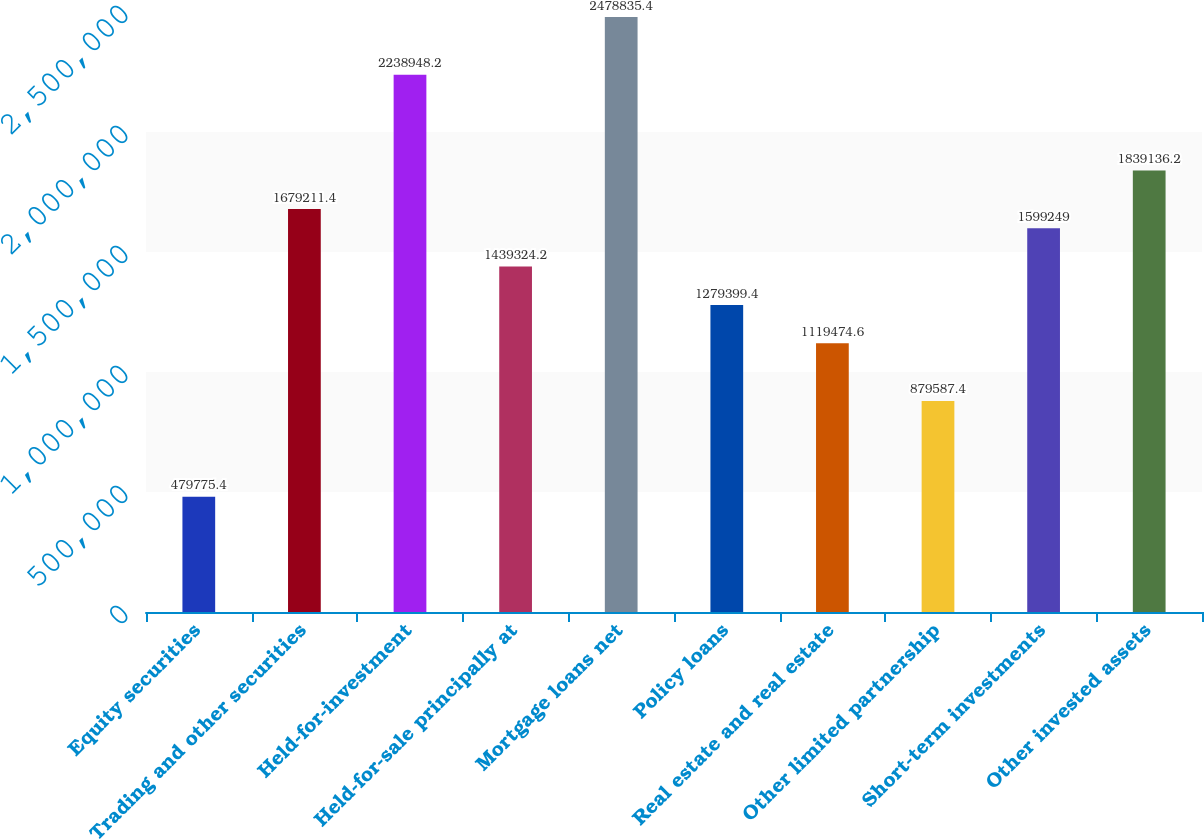Convert chart to OTSL. <chart><loc_0><loc_0><loc_500><loc_500><bar_chart><fcel>Equity securities<fcel>Trading and other securities<fcel>Held-for-investment<fcel>Held-for-sale principally at<fcel>Mortgage loans net<fcel>Policy loans<fcel>Real estate and real estate<fcel>Other limited partnership<fcel>Short-term investments<fcel>Other invested assets<nl><fcel>479775<fcel>1.67921e+06<fcel>2.23895e+06<fcel>1.43932e+06<fcel>2.47884e+06<fcel>1.2794e+06<fcel>1.11947e+06<fcel>879587<fcel>1.59925e+06<fcel>1.83914e+06<nl></chart> 